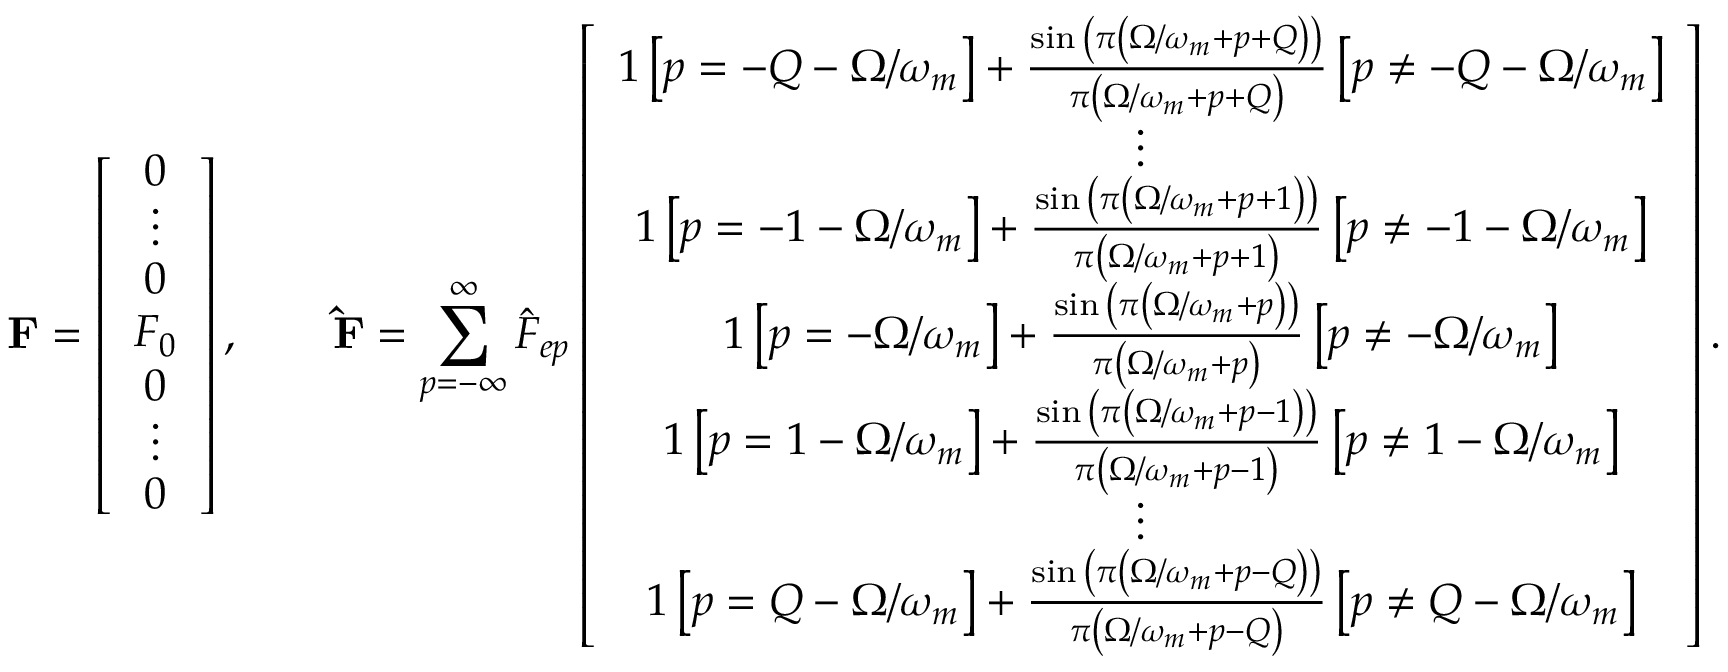<formula> <loc_0><loc_0><loc_500><loc_500>F = \left [ \begin{array} { c c c c c c c } { 0 } \\ { \vdots } \\ { 0 } \\ { F _ { 0 } } \\ { 0 } \\ { \vdots } \\ { 0 } \end{array} \right ] , \quad \hat { F } = \sum _ { p = - \infty } ^ { \infty } \hat { F } _ { e p } \left [ \begin{array} { c c c c c c c } { 1 \left [ p = - Q - \Omega / \omega _ { m } \right ] + \frac { \sin { \left ( \pi \left ( \Omega / \omega _ { m } + p + Q \right ) \right ) } } { \pi \left ( \Omega / \omega _ { m } + p + Q \right ) } \left [ p \neq - Q - \Omega / \omega _ { m } \right ] } \\ { \vdots } \\ { 1 \left [ p = - 1 - \Omega / \omega _ { m } \right ] + \frac { \sin { \left ( \pi \left ( \Omega / \omega _ { m } + p + 1 \right ) \right ) } } { \pi \left ( \Omega / \omega _ { m } + p + 1 \right ) } \left [ p \neq - 1 - \Omega / \omega _ { m } \right ] } \\ { 1 \left [ p = - \Omega / \omega _ { m } \right ] + \frac { \sin { \left ( \pi \left ( \Omega / \omega _ { m } + p \right ) \right ) } } { \pi \left ( \Omega / \omega _ { m } + p \right ) } \left [ p \neq - \Omega / \omega _ { m } \right ] } \\ { 1 \left [ p = 1 - \Omega / \omega _ { m } \right ] + \frac { \sin { \left ( \pi \left ( \Omega / \omega _ { m } + p - 1 \right ) \right ) } } { \pi \left ( \Omega / \omega _ { m } + p - 1 \right ) } \left [ p \neq 1 - \Omega / \omega _ { m } \right ] } \\ { \vdots } \\ { 1 \left [ p = Q - \Omega / \omega _ { m } \right ] + \frac { \sin { \left ( \pi \left ( \Omega / \omega _ { m } + p - Q \right ) \right ) } } { \pi \left ( \Omega / \omega _ { m } + p - Q \right ) } \left [ p \neq Q - \Omega / \omega _ { m } \right ] } \end{array} \right ] .</formula> 